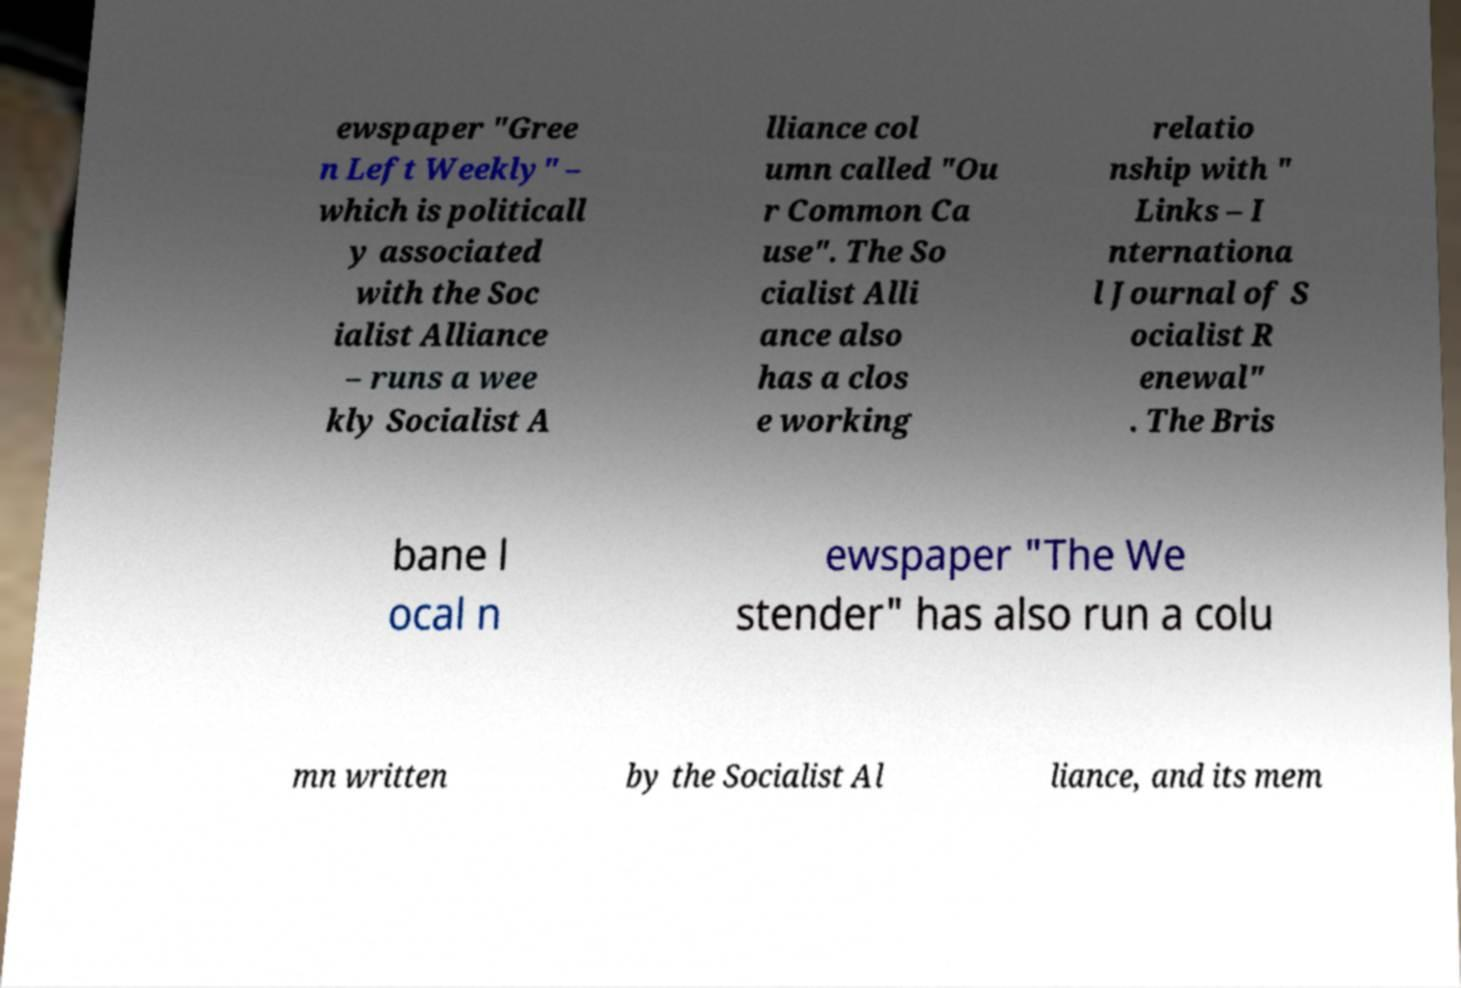For documentation purposes, I need the text within this image transcribed. Could you provide that? ewspaper "Gree n Left Weekly" – which is politicall y associated with the Soc ialist Alliance – runs a wee kly Socialist A lliance col umn called "Ou r Common Ca use". The So cialist Alli ance also has a clos e working relatio nship with " Links – I nternationa l Journal of S ocialist R enewal" . The Bris bane l ocal n ewspaper "The We stender" has also run a colu mn written by the Socialist Al liance, and its mem 